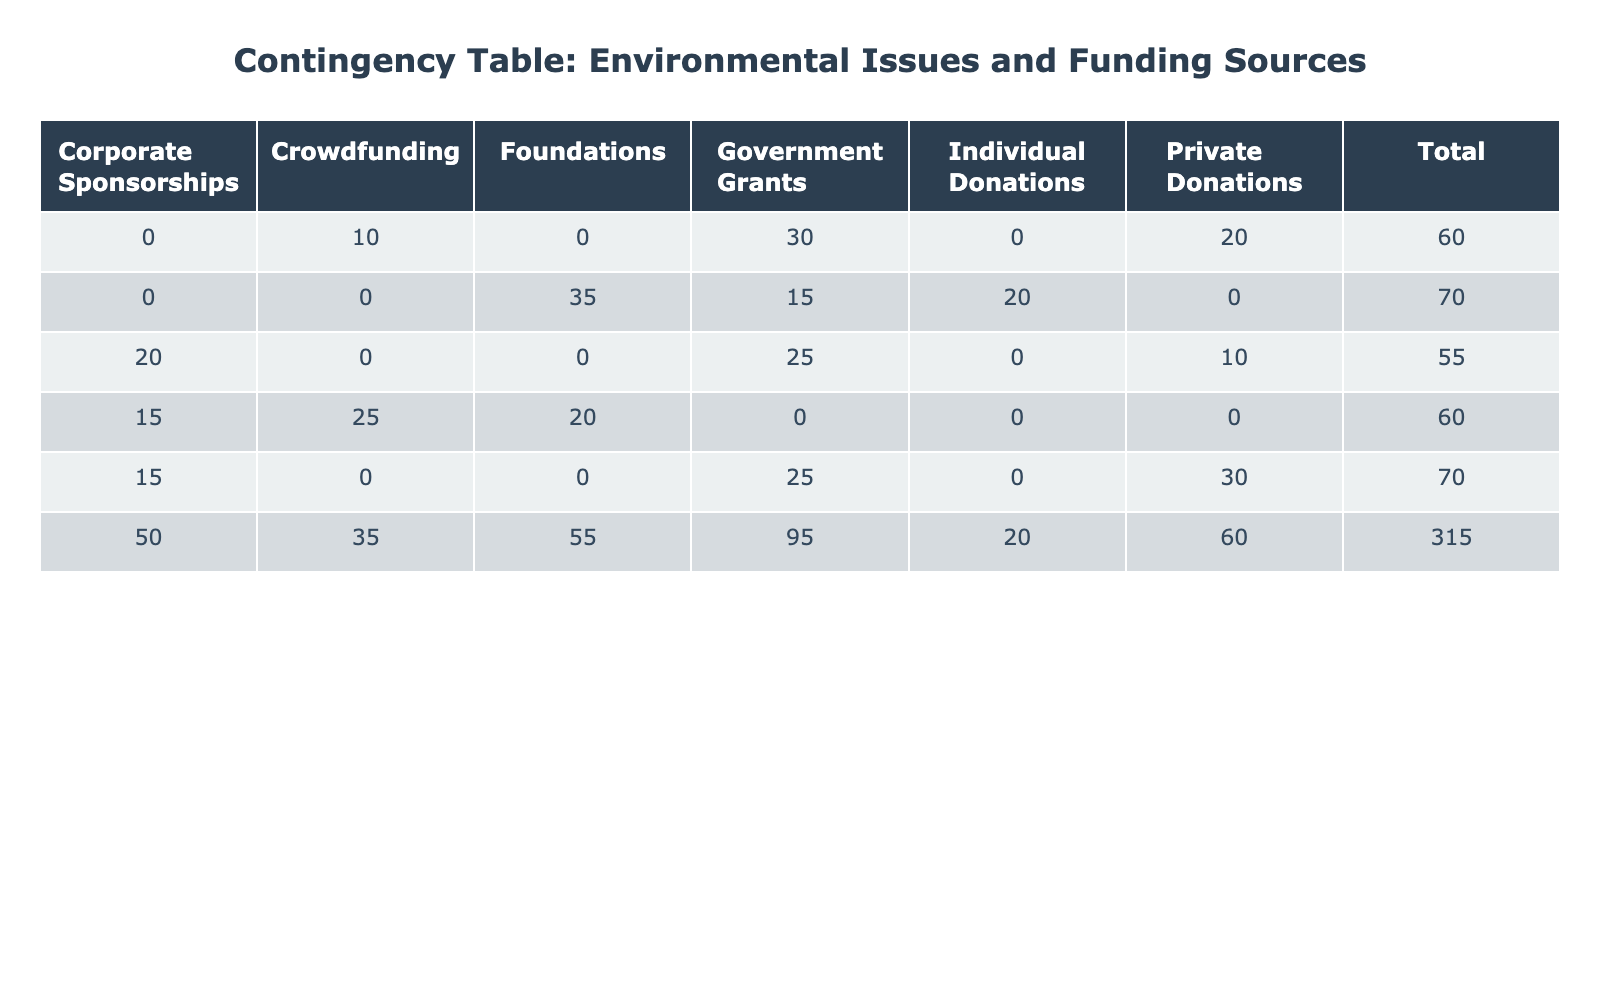What percentage of organizations address Air Quality issues? By looking at the "Air Quality" row in the table, we see that there are percentages listed under different funding sources: 30 for Government Grants, 20 for Private Donations, and 10 for Crowdfunding. Therefore, to find the total percentage of organizations addressing Air Quality, we simply sum these values: 30 + 20 + 10 = 60.
Answer: 60 Which funding source has the highest percentage for Biodiversity Conservation? In the row for "Biodiversity Conservation," we observe the percentages for different funding sources: 35 for Foundations, 20 for Individual Donations, and 15 for Government Grants. The highest percentage among these is 35, attributed to the Foundations funding source.
Answer: 35 Is Private Donations a funding source for Waste Management? In the "Waste Management" row of the table, we check for the Private Donations funding source. Since there is no percentage listed for Private Donations in this row, we can conclude that it is not a funding source for Waste Management.
Answer: No What is the total percentage of organizations funded by Government Grants across all environmental issues? To find the total percentage of organizations funded by Government Grants, we look at each row to find the percentage associated with this funding source. The values are: 30 (Air Quality) + 25 (Water Conservation) + 15 (Biodiversity Conservation) + 25 (Climate Change Advocacy) = 95. Thus, the total is 95.
Answer: 95 How does the percentage of organizations funded by Corporate Sponsorships compare between Climate Change Advocacy and Waste Management? For Climate Change Advocacy, the percentage from Corporate Sponsorships is 20, while for Waste Management, it is 15. Comparing these percentage values shows that Climate Change Advocacy has a higher percentage than Waste Management by 5 (20 - 15 = 5).
Answer: Climate Change Advocacy is higher by 5 What is the total percentage of organizations focused on Water Conservation and funded by Private Donations? To find this, we first look at Water Conservation and see that it has a percentage of 30 for Private Donations. There are no calculations needed since we are only interested in that single value.
Answer: 30 Which environmental issue combined has more funding from Foundations: Waste Management or Biodiversity Conservation? For Waste Management, the percentage from Foundations is 20, while for Biodiversity Conservation, it is 35. When comparing these two values, Biodiversity Conservation has more funding from Foundations than Waste Management by 15 (35 - 20).
Answer: Biodiversity Conservation is higher by 15 What is the average percentage of organizations addressing Climate Change Advocacy through Government Grants and Private Donations? From the table, the percentage for Government Grants is 25 and for Private Donations is 10. To calculate the average percentage, we sum these values: 25 + 10 = 35, then divide by the number of funding sources, which is 2. Therefore, the average percentage is 35 / 2 = 17.5.
Answer: 17.5 Are there any environmental issues that do not receive funding from Corporate Sponsorships? In the table, we check each row to see if Corporate Sponsorships have a percentage listed. We see that Air Quality, Water Conservation, and Biodiversity Conservation do not have a percentage under Corporate Sponsorships, indicating that they do not receive funding from this source. Thus, the answer is yes, there are.
Answer: Yes 